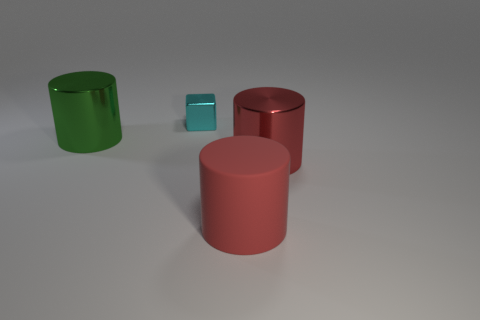There is a object that is both behind the big red shiny object and in front of the tiny cube; what is it made of?
Offer a very short reply. Metal. There is a thing that is to the left of the tiny cyan cube; is its shape the same as the large metallic object to the right of the tiny cyan metallic thing?
Provide a succinct answer. Yes. Is the number of large metal cylinders greater than the number of cubes?
Provide a succinct answer. Yes. The red rubber cylinder is what size?
Ensure brevity in your answer.  Large. How many other things are the same color as the large rubber cylinder?
Your answer should be very brief. 1. Are the red thing in front of the red metal object and the tiny block made of the same material?
Your response must be concise. No. Is the number of small cyan objects on the left side of the red metal cylinder less than the number of big cylinders to the right of the tiny cyan block?
Your answer should be compact. Yes. What number of other objects are there of the same material as the tiny block?
Make the answer very short. 2. There is a green object that is the same size as the red metal object; what is its material?
Make the answer very short. Metal. Are there fewer cyan things that are behind the big green thing than big red objects?
Offer a terse response. Yes. 